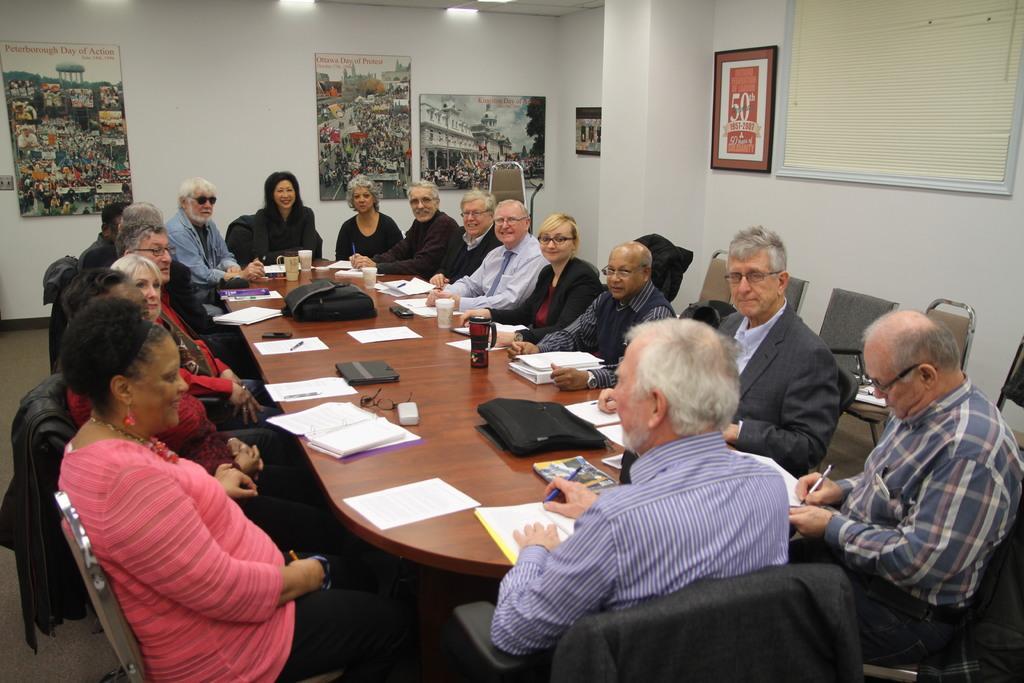Please provide a concise description of this image. A group of people are sitting around a table in a meeting hall. 